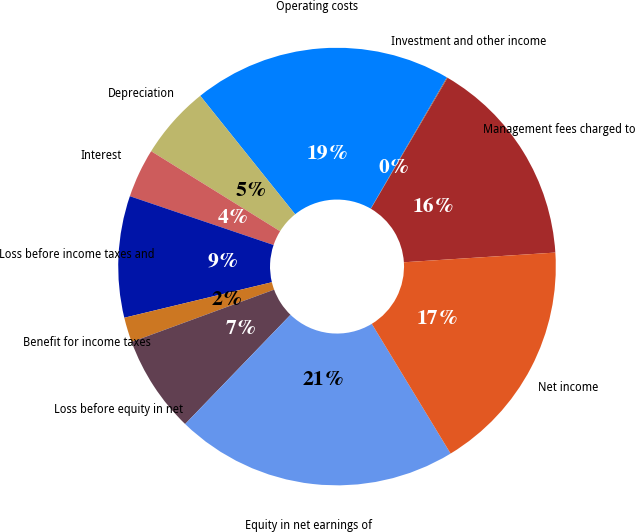Convert chart to OTSL. <chart><loc_0><loc_0><loc_500><loc_500><pie_chart><fcel>Management fees charged to<fcel>Investment and other income<fcel>Operating costs<fcel>Depreciation<fcel>Interest<fcel>Loss before income taxes and<fcel>Benefit for income taxes<fcel>Loss before equity in net<fcel>Equity in net earnings of<fcel>Net income<nl><fcel>15.55%<fcel>0.06%<fcel>19.12%<fcel>5.41%<fcel>3.63%<fcel>8.97%<fcel>1.84%<fcel>7.19%<fcel>20.9%<fcel>17.33%<nl></chart> 